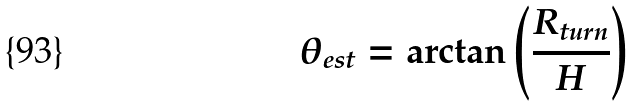Convert formula to latex. <formula><loc_0><loc_0><loc_500><loc_500>\theta _ { e s t } = \arctan \left ( { \frac { { R _ { t u r n } } } { H } } \right )</formula> 